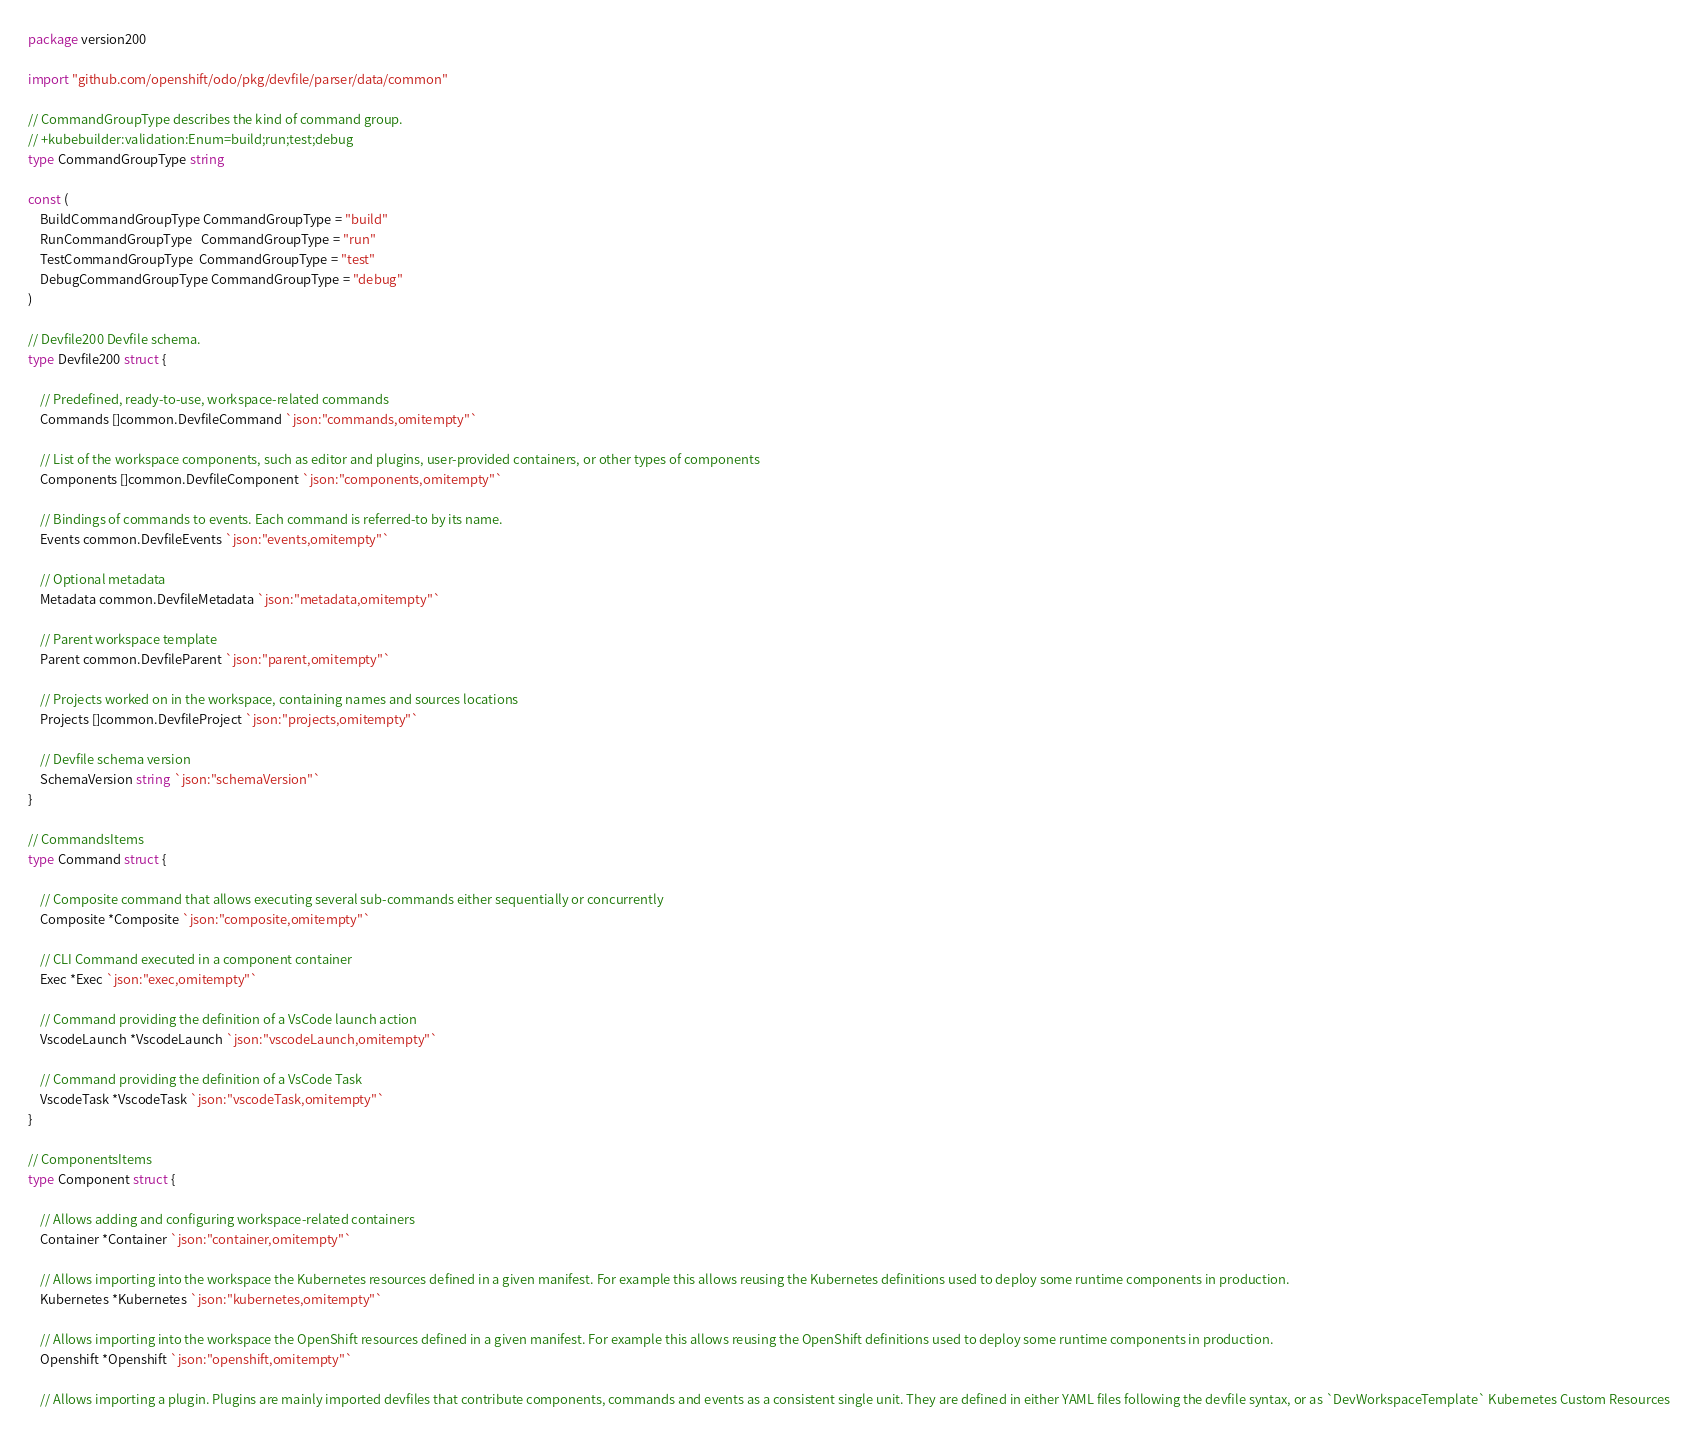<code> <loc_0><loc_0><loc_500><loc_500><_Go_>package version200

import "github.com/openshift/odo/pkg/devfile/parser/data/common"

// CommandGroupType describes the kind of command group.
// +kubebuilder:validation:Enum=build;run;test;debug
type CommandGroupType string

const (
	BuildCommandGroupType CommandGroupType = "build"
	RunCommandGroupType   CommandGroupType = "run"
	TestCommandGroupType  CommandGroupType = "test"
	DebugCommandGroupType CommandGroupType = "debug"
)

// Devfile200 Devfile schema.
type Devfile200 struct {

	// Predefined, ready-to-use, workspace-related commands
	Commands []common.DevfileCommand `json:"commands,omitempty"`

	// List of the workspace components, such as editor and plugins, user-provided containers, or other types of components
	Components []common.DevfileComponent `json:"components,omitempty"`

	// Bindings of commands to events. Each command is referred-to by its name.
	Events common.DevfileEvents `json:"events,omitempty"`

	// Optional metadata
	Metadata common.DevfileMetadata `json:"metadata,omitempty"`

	// Parent workspace template
	Parent common.DevfileParent `json:"parent,omitempty"`

	// Projects worked on in the workspace, containing names and sources locations
	Projects []common.DevfileProject `json:"projects,omitempty"`

	// Devfile schema version
	SchemaVersion string `json:"schemaVersion"`
}

// CommandsItems
type Command struct {

	// Composite command that allows executing several sub-commands either sequentially or concurrently
	Composite *Composite `json:"composite,omitempty"`

	// CLI Command executed in a component container
	Exec *Exec `json:"exec,omitempty"`

	// Command providing the definition of a VsCode launch action
	VscodeLaunch *VscodeLaunch `json:"vscodeLaunch,omitempty"`

	// Command providing the definition of a VsCode Task
	VscodeTask *VscodeTask `json:"vscodeTask,omitempty"`
}

// ComponentsItems
type Component struct {

	// Allows adding and configuring workspace-related containers
	Container *Container `json:"container,omitempty"`

	// Allows importing into the workspace the Kubernetes resources defined in a given manifest. For example this allows reusing the Kubernetes definitions used to deploy some runtime components in production.
	Kubernetes *Kubernetes `json:"kubernetes,omitempty"`

	// Allows importing into the workspace the OpenShift resources defined in a given manifest. For example this allows reusing the OpenShift definitions used to deploy some runtime components in production.
	Openshift *Openshift `json:"openshift,omitempty"`

	// Allows importing a plugin. Plugins are mainly imported devfiles that contribute components, commands and events as a consistent single unit. They are defined in either YAML files following the devfile syntax, or as `DevWorkspaceTemplate` Kubernetes Custom Resources</code> 